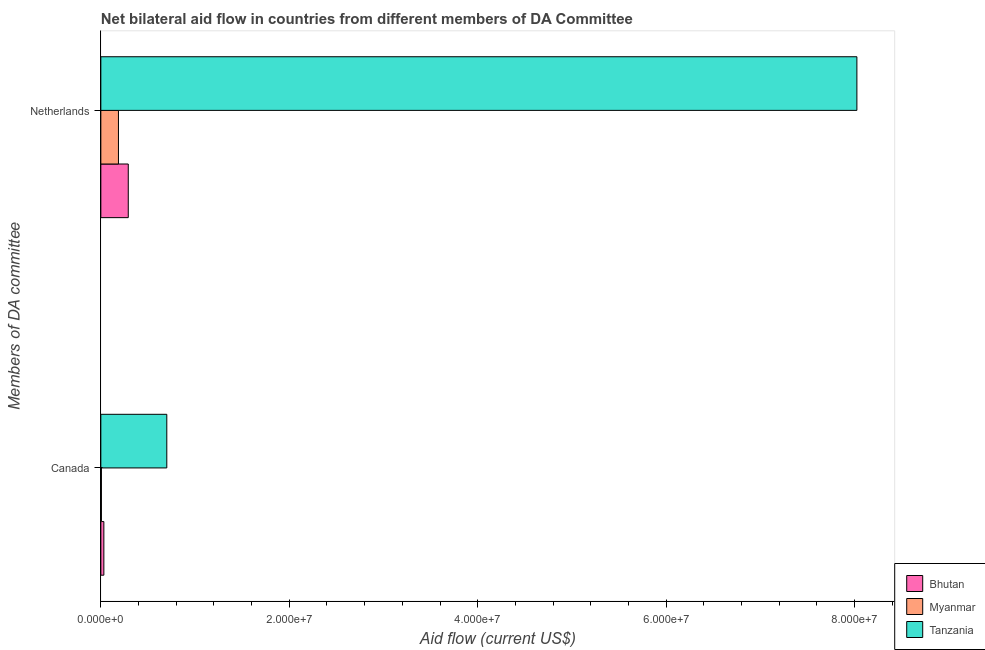Are the number of bars on each tick of the Y-axis equal?
Offer a terse response. Yes. How many bars are there on the 1st tick from the bottom?
Offer a very short reply. 3. What is the label of the 1st group of bars from the top?
Your answer should be very brief. Netherlands. What is the amount of aid given by netherlands in Bhutan?
Keep it short and to the point. 2.91e+06. Across all countries, what is the maximum amount of aid given by netherlands?
Give a very brief answer. 8.02e+07. Across all countries, what is the minimum amount of aid given by canada?
Provide a short and direct response. 6.00e+04. In which country was the amount of aid given by canada maximum?
Your answer should be very brief. Tanzania. In which country was the amount of aid given by netherlands minimum?
Offer a very short reply. Myanmar. What is the total amount of aid given by canada in the graph?
Your response must be concise. 7.38e+06. What is the difference between the amount of aid given by canada in Bhutan and that in Tanzania?
Give a very brief answer. -6.68e+06. What is the difference between the amount of aid given by netherlands in Tanzania and the amount of aid given by canada in Myanmar?
Offer a very short reply. 8.02e+07. What is the average amount of aid given by canada per country?
Give a very brief answer. 2.46e+06. What is the difference between the amount of aid given by netherlands and amount of aid given by canada in Bhutan?
Your answer should be compact. 2.59e+06. What is the ratio of the amount of aid given by canada in Bhutan to that in Tanzania?
Provide a succinct answer. 0.05. Is the amount of aid given by netherlands in Tanzania less than that in Myanmar?
Keep it short and to the point. No. In how many countries, is the amount of aid given by canada greater than the average amount of aid given by canada taken over all countries?
Offer a terse response. 1. What does the 1st bar from the top in Netherlands represents?
Make the answer very short. Tanzania. What does the 1st bar from the bottom in Netherlands represents?
Your response must be concise. Bhutan. How many bars are there?
Ensure brevity in your answer.  6. How many countries are there in the graph?
Ensure brevity in your answer.  3. Are the values on the major ticks of X-axis written in scientific E-notation?
Provide a short and direct response. Yes. Does the graph contain grids?
Give a very brief answer. No. Where does the legend appear in the graph?
Offer a very short reply. Bottom right. What is the title of the graph?
Give a very brief answer. Net bilateral aid flow in countries from different members of DA Committee. What is the label or title of the Y-axis?
Provide a succinct answer. Members of DA committee. What is the Aid flow (current US$) in Bhutan in Canada?
Offer a terse response. 3.20e+05. What is the Aid flow (current US$) of Myanmar in Canada?
Make the answer very short. 6.00e+04. What is the Aid flow (current US$) in Tanzania in Canada?
Ensure brevity in your answer.  7.00e+06. What is the Aid flow (current US$) of Bhutan in Netherlands?
Your answer should be compact. 2.91e+06. What is the Aid flow (current US$) in Myanmar in Netherlands?
Your answer should be compact. 1.87e+06. What is the Aid flow (current US$) in Tanzania in Netherlands?
Keep it short and to the point. 8.02e+07. Across all Members of DA committee, what is the maximum Aid flow (current US$) of Bhutan?
Provide a succinct answer. 2.91e+06. Across all Members of DA committee, what is the maximum Aid flow (current US$) of Myanmar?
Ensure brevity in your answer.  1.87e+06. Across all Members of DA committee, what is the maximum Aid flow (current US$) of Tanzania?
Keep it short and to the point. 8.02e+07. Across all Members of DA committee, what is the minimum Aid flow (current US$) of Myanmar?
Your answer should be compact. 6.00e+04. What is the total Aid flow (current US$) in Bhutan in the graph?
Your response must be concise. 3.23e+06. What is the total Aid flow (current US$) of Myanmar in the graph?
Ensure brevity in your answer.  1.93e+06. What is the total Aid flow (current US$) in Tanzania in the graph?
Make the answer very short. 8.72e+07. What is the difference between the Aid flow (current US$) in Bhutan in Canada and that in Netherlands?
Your answer should be very brief. -2.59e+06. What is the difference between the Aid flow (current US$) of Myanmar in Canada and that in Netherlands?
Your answer should be compact. -1.81e+06. What is the difference between the Aid flow (current US$) of Tanzania in Canada and that in Netherlands?
Provide a succinct answer. -7.32e+07. What is the difference between the Aid flow (current US$) of Bhutan in Canada and the Aid flow (current US$) of Myanmar in Netherlands?
Make the answer very short. -1.55e+06. What is the difference between the Aid flow (current US$) of Bhutan in Canada and the Aid flow (current US$) of Tanzania in Netherlands?
Keep it short and to the point. -7.99e+07. What is the difference between the Aid flow (current US$) in Myanmar in Canada and the Aid flow (current US$) in Tanzania in Netherlands?
Give a very brief answer. -8.02e+07. What is the average Aid flow (current US$) in Bhutan per Members of DA committee?
Make the answer very short. 1.62e+06. What is the average Aid flow (current US$) in Myanmar per Members of DA committee?
Ensure brevity in your answer.  9.65e+05. What is the average Aid flow (current US$) in Tanzania per Members of DA committee?
Your answer should be very brief. 4.36e+07. What is the difference between the Aid flow (current US$) in Bhutan and Aid flow (current US$) in Tanzania in Canada?
Your answer should be compact. -6.68e+06. What is the difference between the Aid flow (current US$) of Myanmar and Aid flow (current US$) of Tanzania in Canada?
Provide a short and direct response. -6.94e+06. What is the difference between the Aid flow (current US$) in Bhutan and Aid flow (current US$) in Myanmar in Netherlands?
Give a very brief answer. 1.04e+06. What is the difference between the Aid flow (current US$) in Bhutan and Aid flow (current US$) in Tanzania in Netherlands?
Give a very brief answer. -7.73e+07. What is the difference between the Aid flow (current US$) of Myanmar and Aid flow (current US$) of Tanzania in Netherlands?
Provide a succinct answer. -7.84e+07. What is the ratio of the Aid flow (current US$) in Bhutan in Canada to that in Netherlands?
Keep it short and to the point. 0.11. What is the ratio of the Aid flow (current US$) of Myanmar in Canada to that in Netherlands?
Offer a terse response. 0.03. What is the ratio of the Aid flow (current US$) of Tanzania in Canada to that in Netherlands?
Provide a short and direct response. 0.09. What is the difference between the highest and the second highest Aid flow (current US$) in Bhutan?
Your answer should be compact. 2.59e+06. What is the difference between the highest and the second highest Aid flow (current US$) in Myanmar?
Offer a terse response. 1.81e+06. What is the difference between the highest and the second highest Aid flow (current US$) of Tanzania?
Make the answer very short. 7.32e+07. What is the difference between the highest and the lowest Aid flow (current US$) of Bhutan?
Make the answer very short. 2.59e+06. What is the difference between the highest and the lowest Aid flow (current US$) of Myanmar?
Give a very brief answer. 1.81e+06. What is the difference between the highest and the lowest Aid flow (current US$) in Tanzania?
Provide a short and direct response. 7.32e+07. 